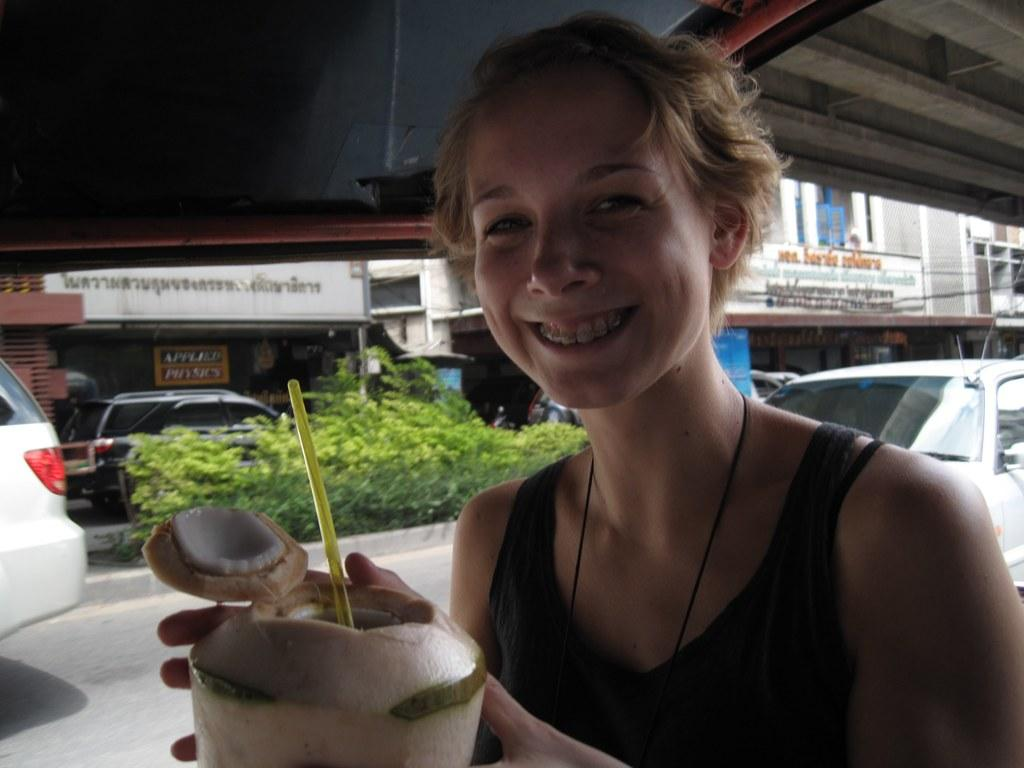Who is present in the image? There is a lady in the image. What is the lady holding in the image? The lady is holding a tender coconut with a straw. What can be seen in the background of the image? There are plants, vehicles, and buildings with name boards in the background of the image. What type of vest is the lady wearing in the image? The lady is not wearing a vest in the image. Are there any clams visible in the image? There are no clams present in the image. 